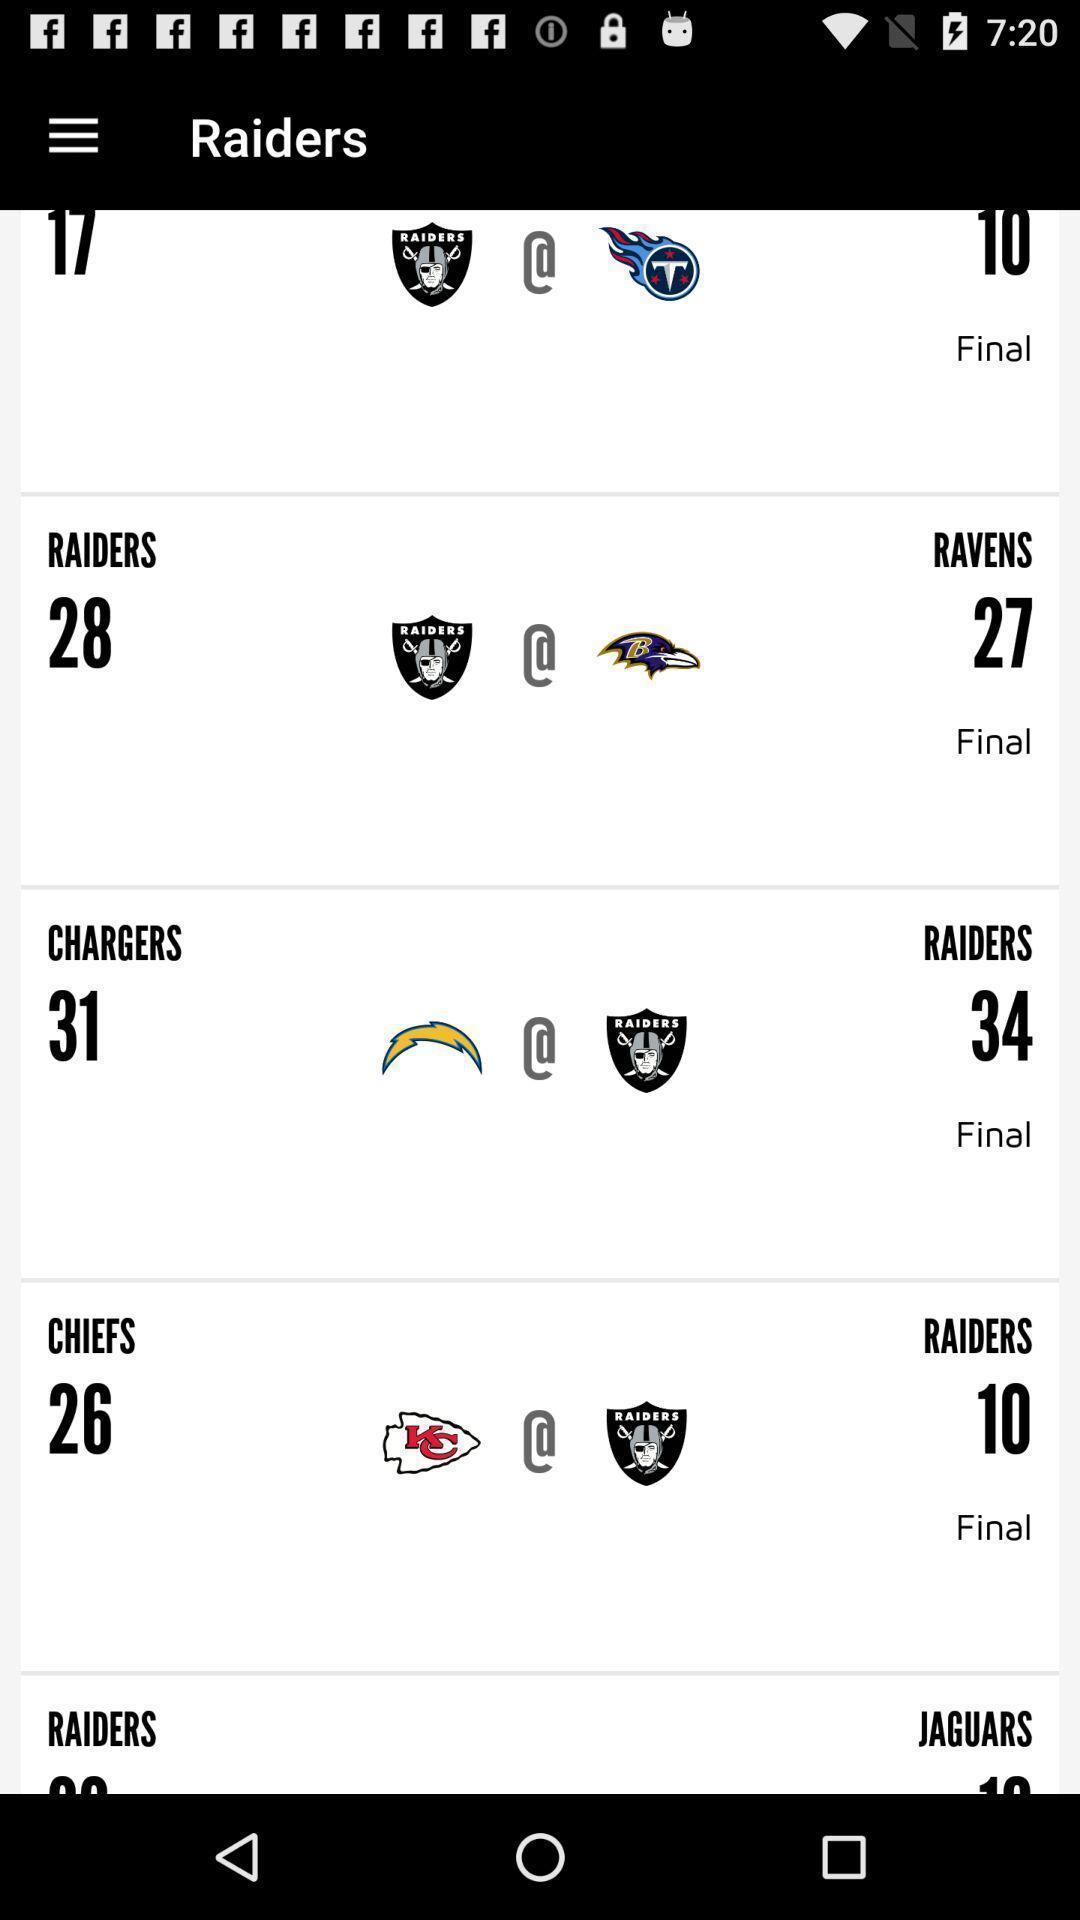Give me a narrative description of this picture. Page showing scores of raiders on an app. 